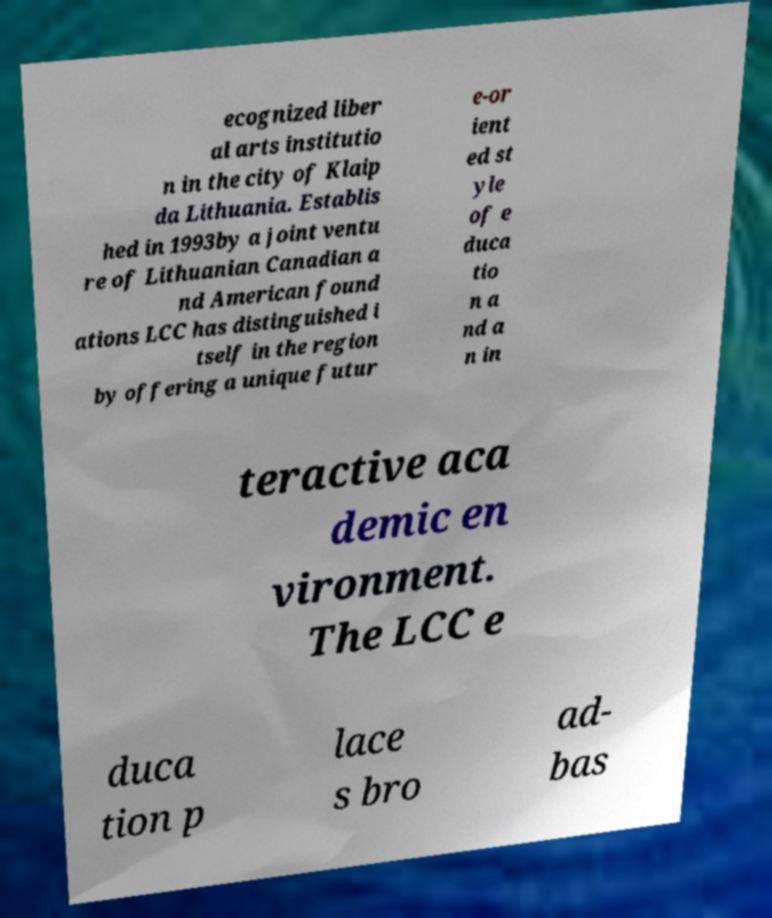I need the written content from this picture converted into text. Can you do that? ecognized liber al arts institutio n in the city of Klaip da Lithuania. Establis hed in 1993by a joint ventu re of Lithuanian Canadian a nd American found ations LCC has distinguished i tself in the region by offering a unique futur e-or ient ed st yle of e duca tio n a nd a n in teractive aca demic en vironment. The LCC e duca tion p lace s bro ad- bas 